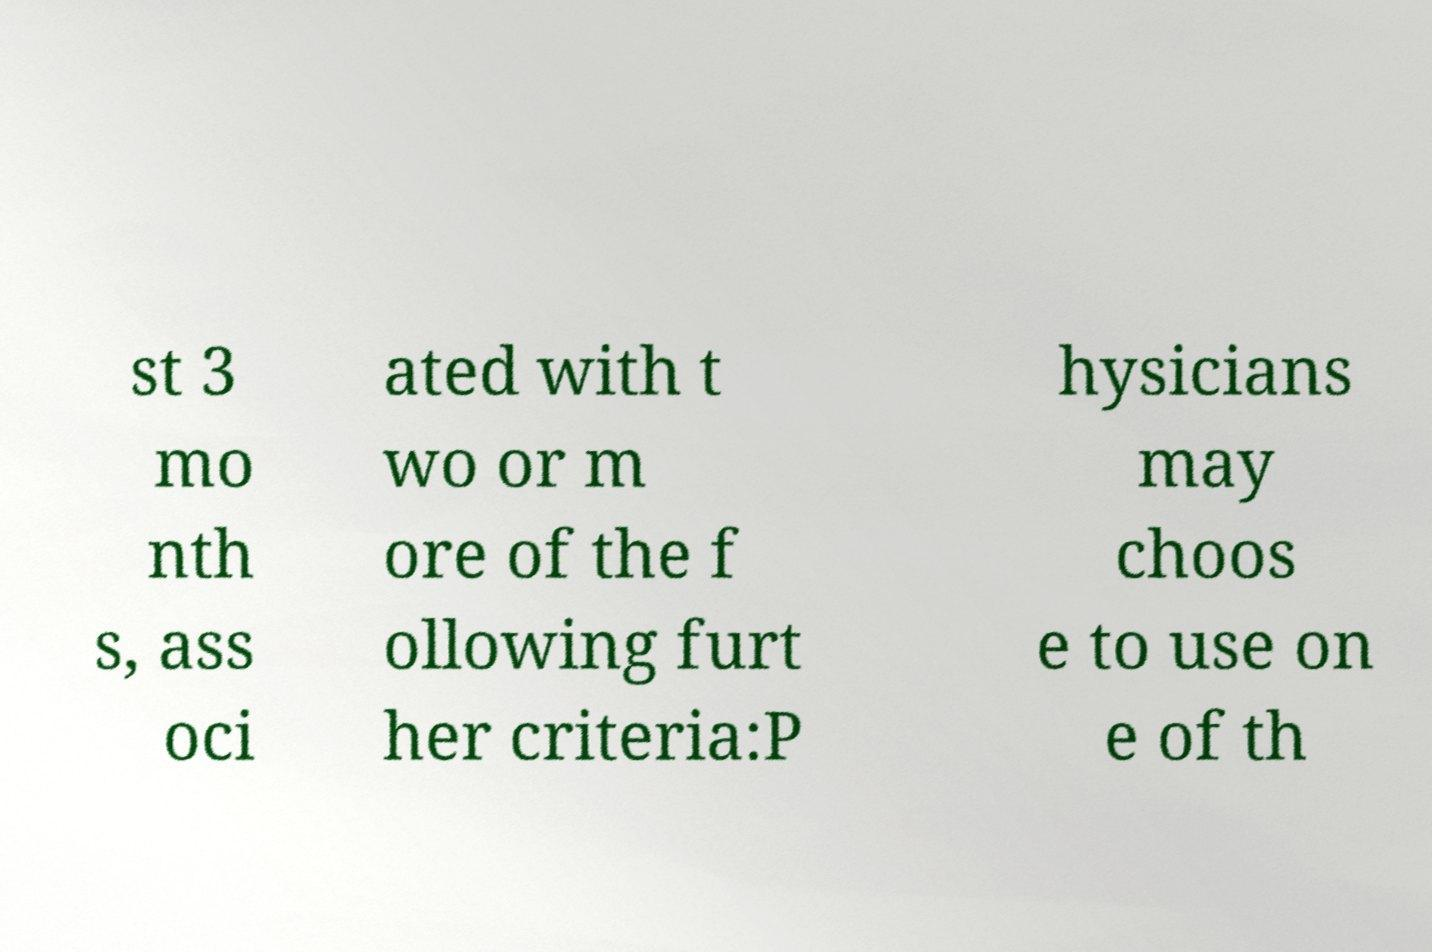Can you read and provide the text displayed in the image?This photo seems to have some interesting text. Can you extract and type it out for me? st 3 mo nth s, ass oci ated with t wo or m ore of the f ollowing furt her criteria:P hysicians may choos e to use on e of th 